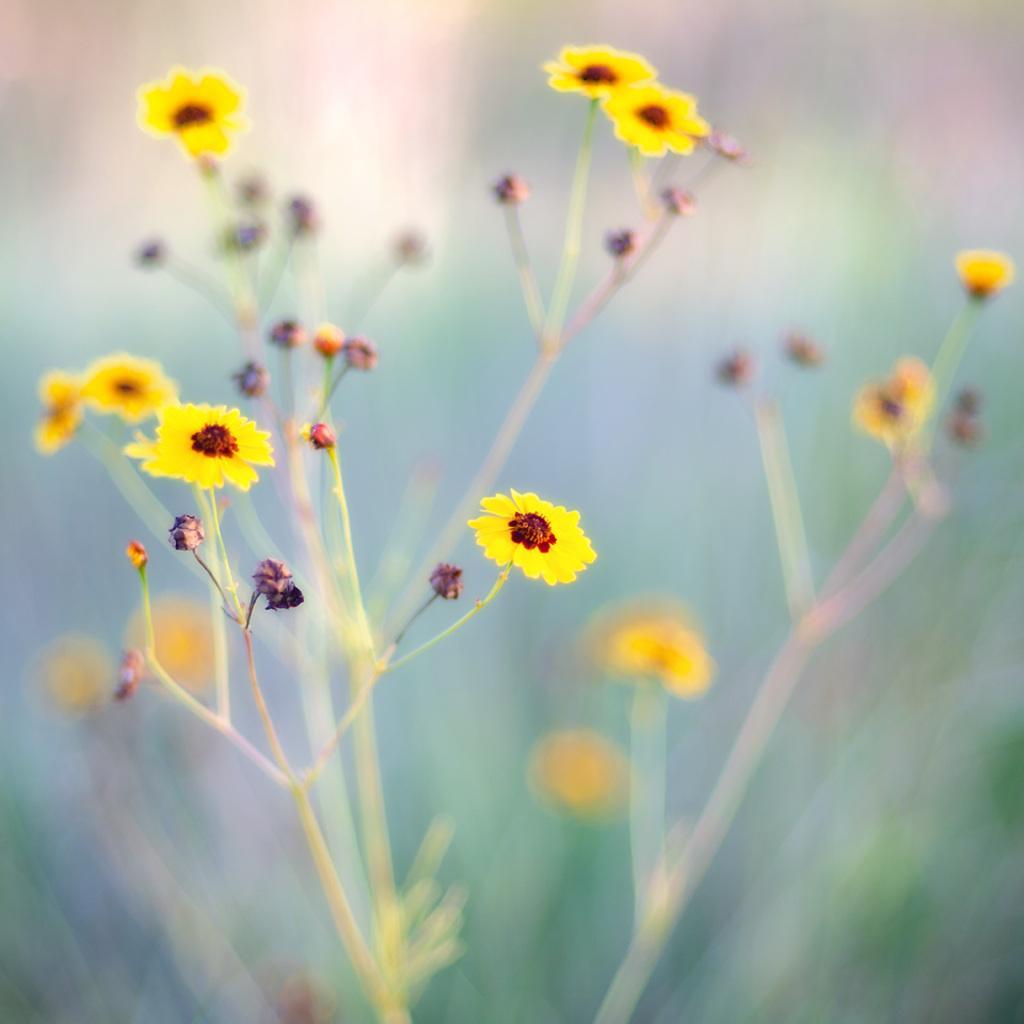Describe this image in one or two sentences. In the image there is a plant with yellow color flowers and the background is blurry. 